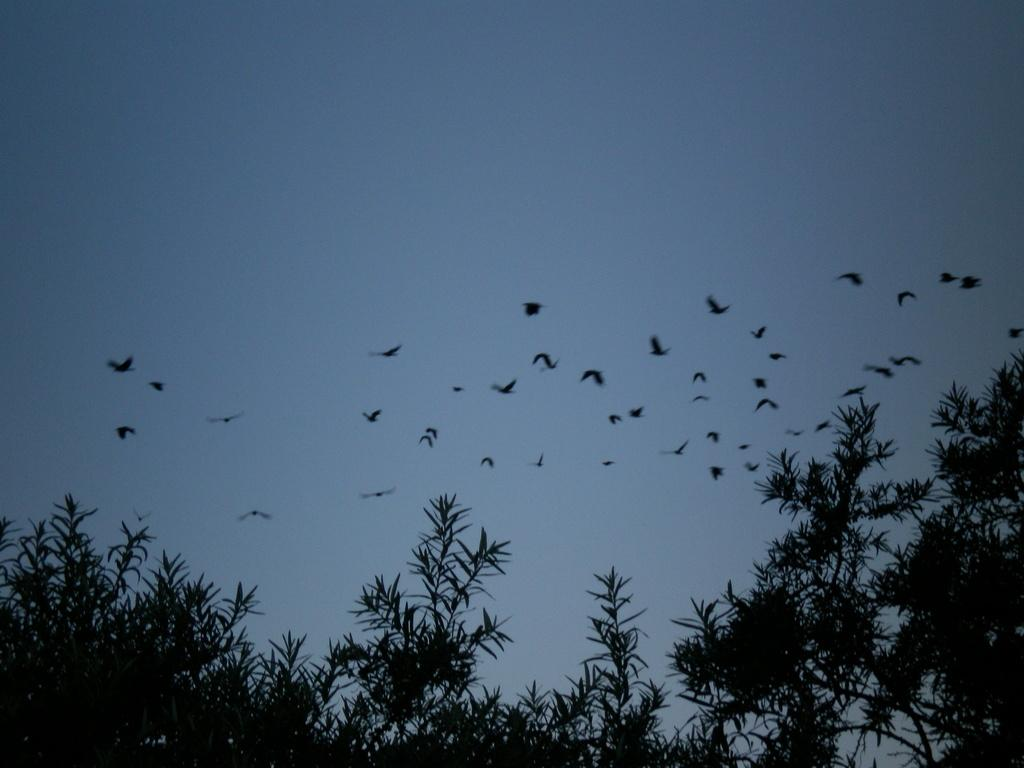What is happening in the sky in the image? There are birds flying in the sky in the image. What can be seen at the bottom of the image? Trees are visible at the bottom of the image. What else is present in the sky besides the birds? There are clouds in the sky in the image. How much fear do the birds exhibit while flying in the image? There is no indication of fear in the image; the birds are simply flying. 